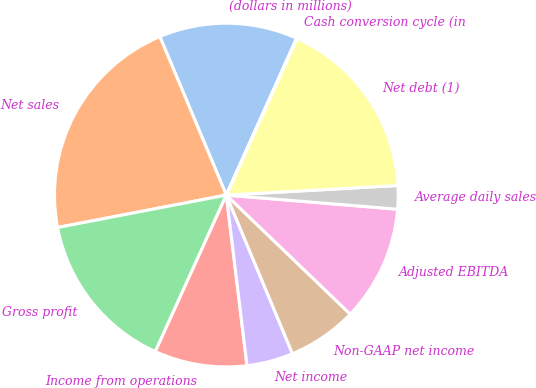Convert chart to OTSL. <chart><loc_0><loc_0><loc_500><loc_500><pie_chart><fcel>(dollars in millions)<fcel>Net sales<fcel>Gross profit<fcel>Income from operations<fcel>Net income<fcel>Non-GAAP net income<fcel>Adjusted EBITDA<fcel>Average daily sales<fcel>Net debt (1)<fcel>Cash conversion cycle (in<nl><fcel>13.03%<fcel>21.7%<fcel>15.2%<fcel>8.7%<fcel>4.37%<fcel>6.53%<fcel>10.87%<fcel>2.2%<fcel>17.37%<fcel>0.04%<nl></chart> 